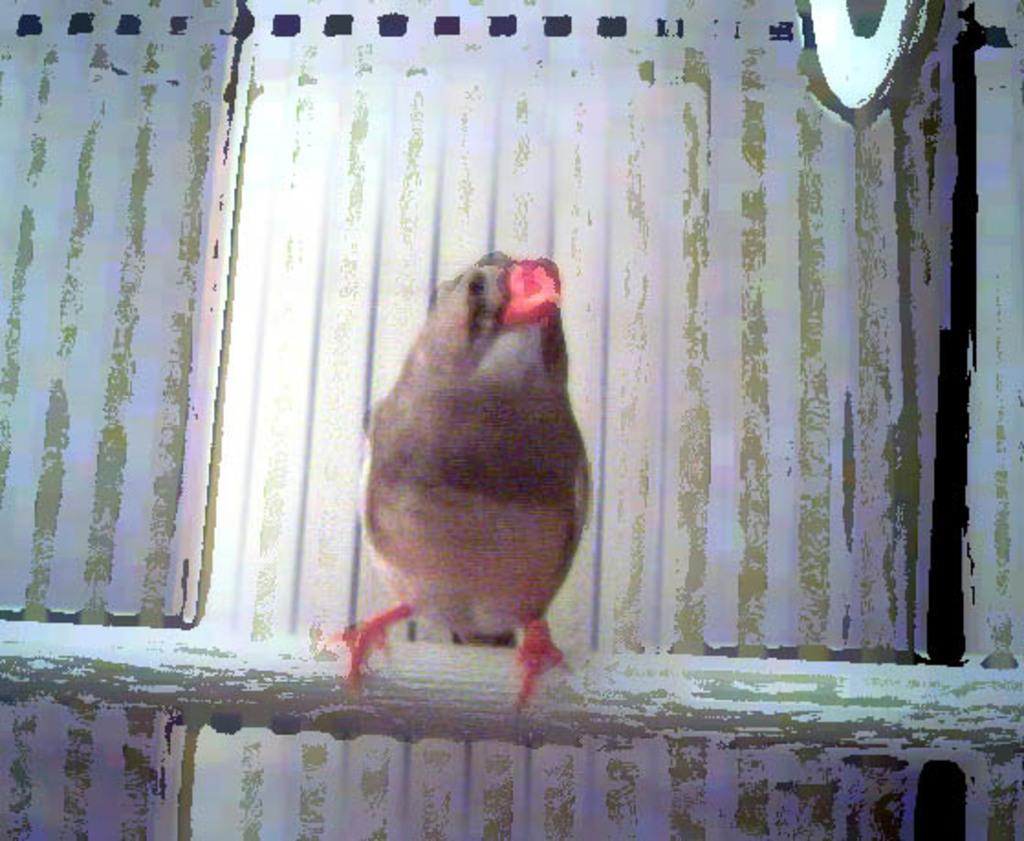What type of animal can be seen in the image? There is a bird in the image. What color is the background of the image? The background of the image appears to be white in color. What type of bead is the bird wearing during the feast in the image? There is no bead or feast present in the image, and the bird is not wearing any accessories. 